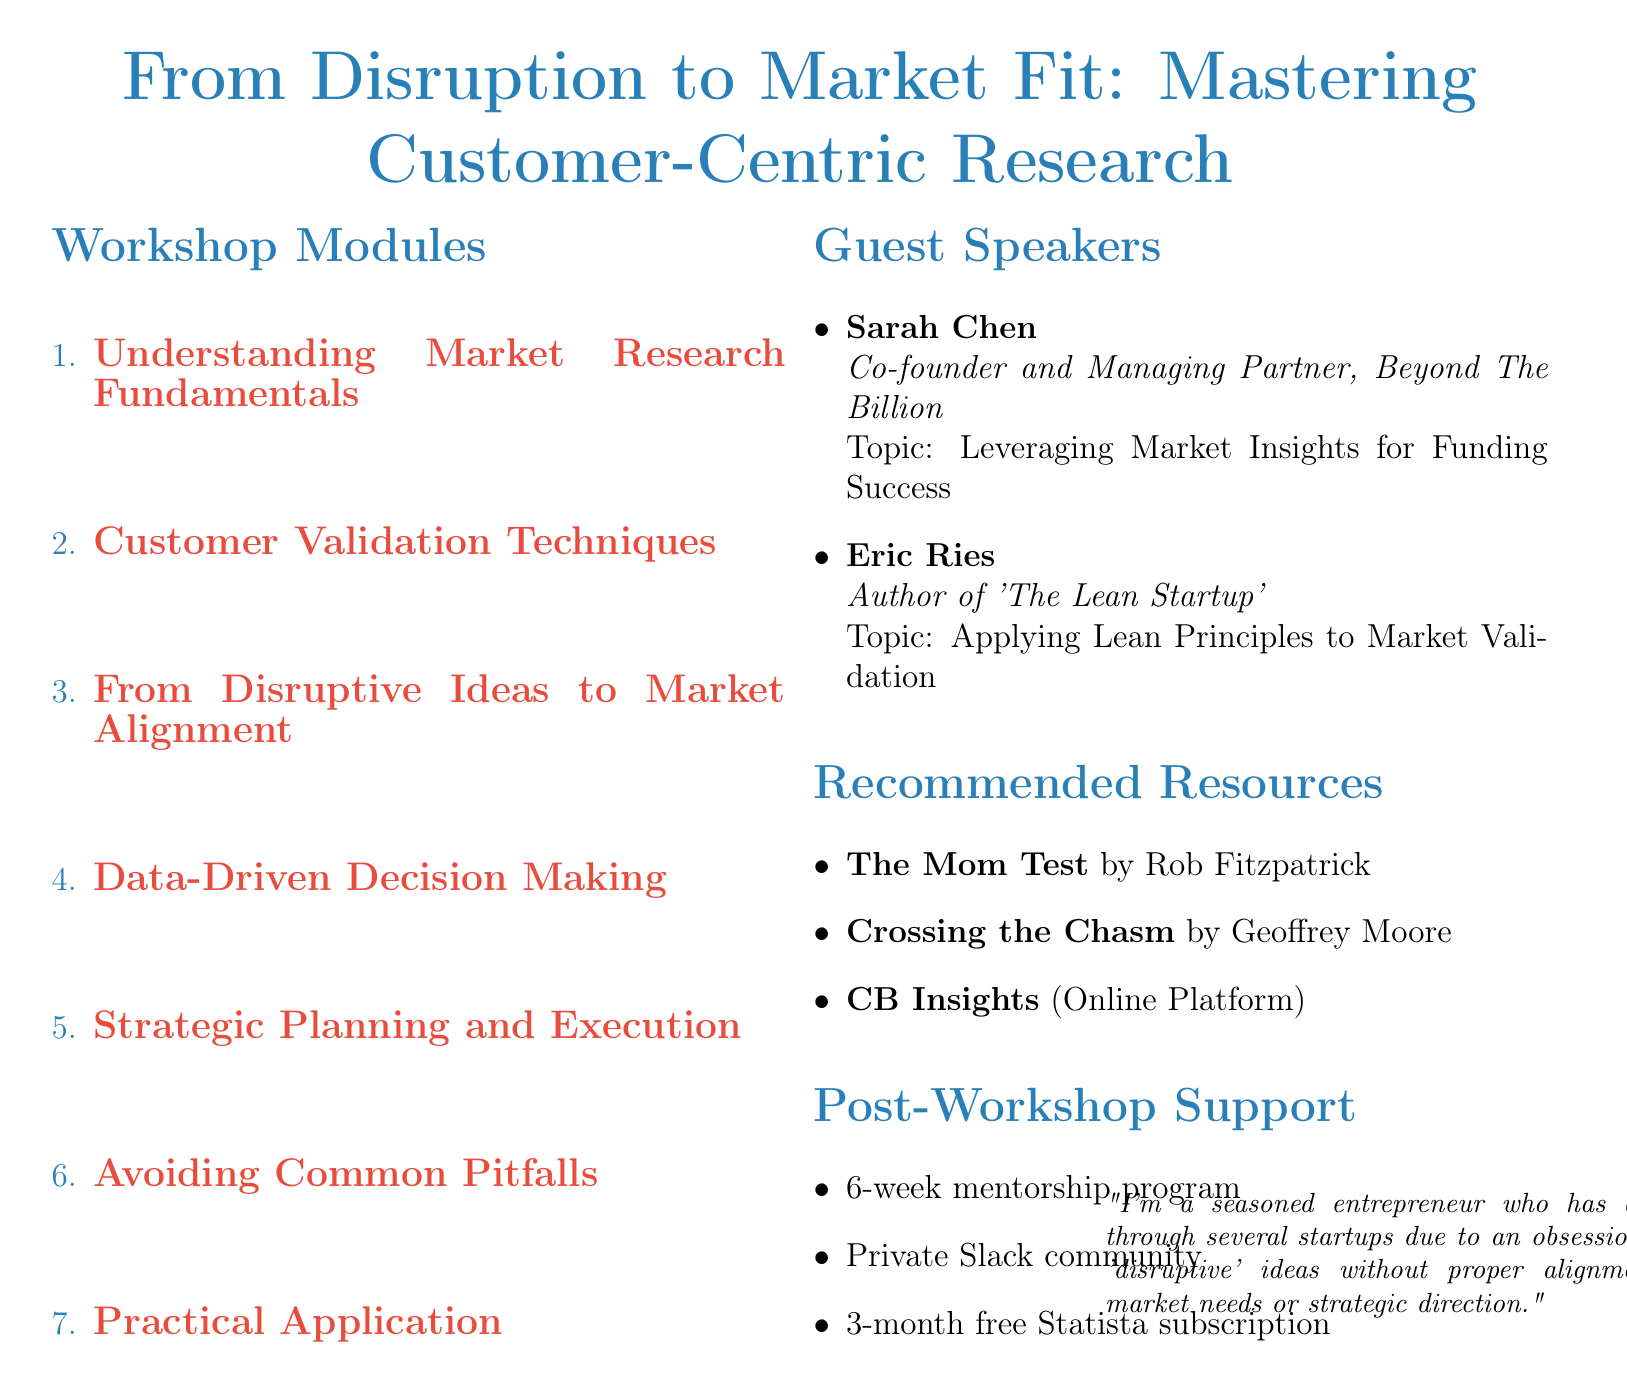What is the workshop title? The workshop title is prominently displayed at the top of the document.
Answer: From Disruption to Market Fit: Mastering Customer-Centric Research Who is the first guest speaker? The guest speakers are listed in the section dedicated to them, where names and titles are provided.
Answer: Sarah Chen How many modules are included in the workshop? The modules are listed in a numbered format, which indicates the total count.
Answer: 7 What method is used to create customer personas? The techniques are specified under the relevant module that addresses customer validation.
Answer: Empathy maps Which resource focuses on talking to customers? The recommended resources section lists various references focusing on market research and customer interaction.
Answer: The Mom Test What type of support is offered after the workshop? The post-workshop support section outlines various types of support available for participants.
Answer: Mentorship program What is the subject of Eric Ries's talk? The subject of each guest speaker's talk is mentioned alongside their name in the document.
Answer: Applying Lean Principles to Market Validation What methodology is utilized for market validation? This concept is highlighted under the customer validation techniques module and specifies a systematic approach.
Answer: Lean Startup methodology What is the case study example during the workshop? The case study is mentioned within the module that discusses aligning disruptive ideas with market needs.
Answer: Airbnb's journey from concept to market fit 